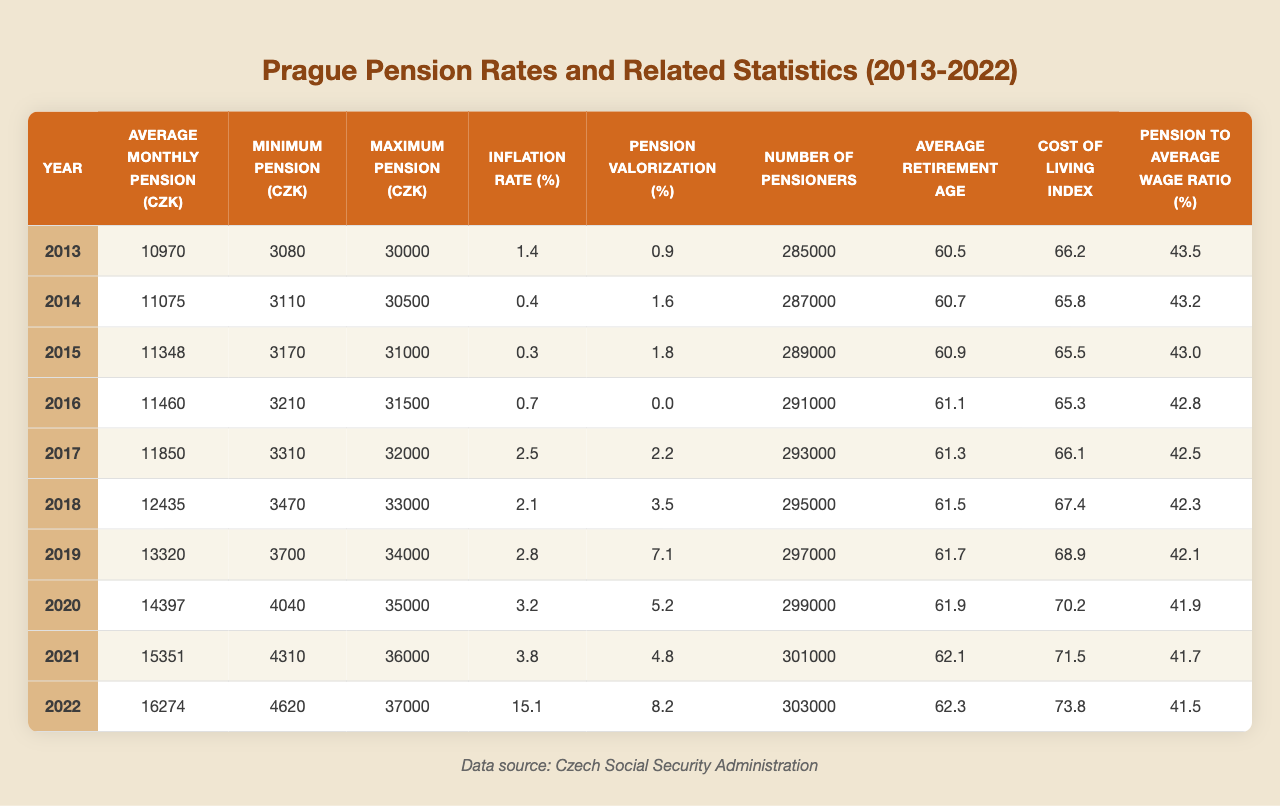What was the average monthly pension in Prague in 2020? According to the table, the average monthly pension in Prague in 2020 is listed as 14,397 CZK.
Answer: 14,397 CZK What is the minimum pension in 2017? The minimum pension in 2017 is provided in the table, showing a value of 3,310 CZK.
Answer: 3,310 CZK Was the inflation rate higher in 2022 than in previous years? In 2022, the inflation rate is shown as 15.1%, which is significantly higher compared to the previous years, all of which had rates below 4%.
Answer: Yes What was the change in the average monthly pension from 2013 to 2022? The average monthly pension increased from 10,970 CZK in 2013 to 16,274 CZK in 2022. The change is calculated as 16,274 - 10,970 = 5,304 CZK.
Answer: 5,304 CZK Is the average retirement age consistently increasing over the decade? The average retirement age shows an upward trend each year from 60.5 in 2013 to 62.3 in 2022, indicating a consistent increase.
Answer: Yes Which year had the highest number of pensioners in Prague? The table shows that in 2022, there were 303,000 pensioners, the highest number during the entire decade from 2013 to 2022.
Answer: 2022 What was the average pension to average wage ratio in 2019? The ratio calculated for 2019 is 42.1%, as stated in the table for that year.
Answer: 42.1% How much did the minimum pension increase from 2015 to 2020? The minimum pension in 2015 was 3,170 CZK, and in 2020 it was 4,040 CZK. The increase is calculated as 4,040 - 3,170 = 870 CZK.
Answer: 870 CZK What can be said about the correlation between inflation rate and pension valorization in 2022? In 2022, the inflation rate is 15.1%, while pension valorization is 8.2%. Although both figures are significant, inflation outpaced the valorization, suggesting pension adjustments may not fully cover inflation.
Answer: Inflation was higher than pension valorization What was the average monthly pension in the year with the lowest minimum pension? The year with the lowest minimum pension is 2013 at 3,080 CZK. In the same year, the average monthly pension is 10,970 CZK.
Answer: 10,970 CZK 